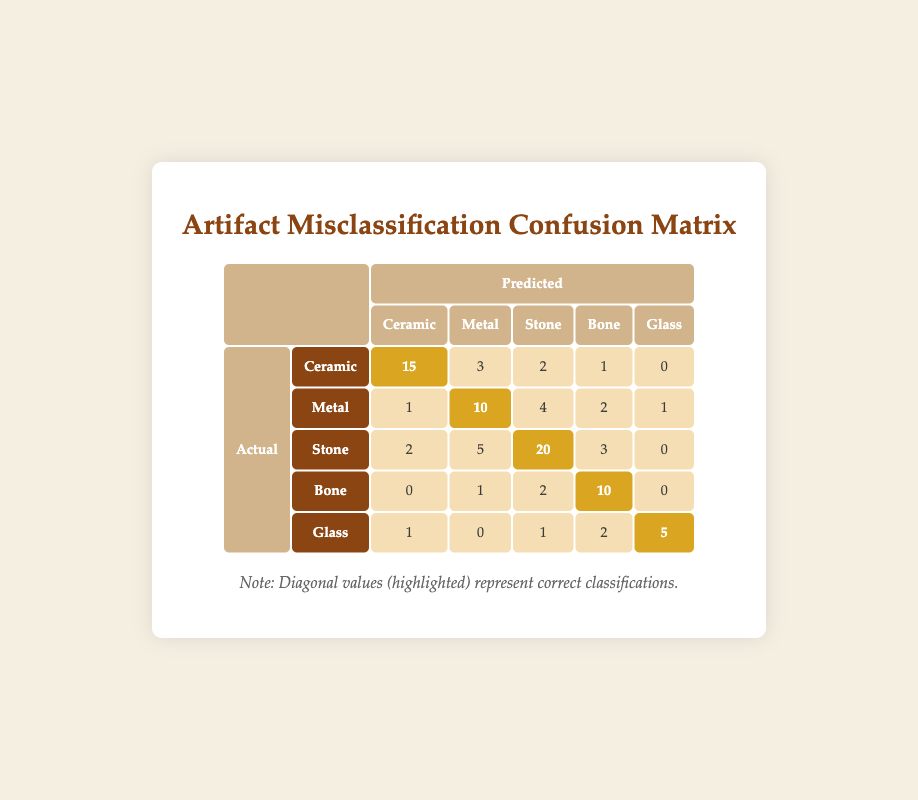What is the predicted number of Ceramic artifacts that were correctly classified? Referring to the diagonal entry in the table for Ceramic, the predicted number that was correctly classified is highlighted and shows 15.
Answer: 15 How many Metal artifacts were misclassified as Stone? In the row for Metal artifacts, look at the column for Stone. The value is 4, indicating that 4 Metal artifacts were misclassified as Stone.
Answer: 4 What is the total number of artifacts that were actually classified as Bone? To find this, sum the entire row for Bone: 0 + 1 + 2 + 10 + 0 = 13. Thus, the total number of artifacts that were actually classified as Bone is 13.
Answer: 13 Is the number of Glass artifacts correctly classified higher than those misclassified as Ceramic? The correctly classified Glass artifacts are 5 (the diagonal entry), while the number misclassified as Ceramic is 1. Since 5 is greater than 1, the statement is true.
Answer: Yes What is the average number of misclassifications for each type of artifact? To calculate the average, first sum the misclassifications for each artifact by taking the total of the off-diagonal entries. The totals are: Ceramic (3 + 2 + 1 + 0) = 6, Metal (1 + 4 + 2 + 1) = 8, Stone (2 + 5 + 3 + 0) = 10, Bone (0 + 1 + 2 + 0) = 3, Glass (1 + 0 + 2) = 3. This results in a total of 30 misclassifications across 5 artifact types, giving an average of 30/5 = 6.
Answer: 6 